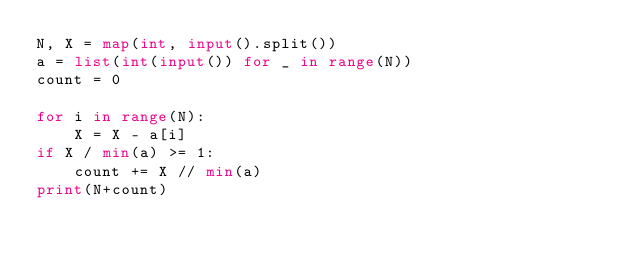<code> <loc_0><loc_0><loc_500><loc_500><_Python_>N, X = map(int, input().split())
a = list(int(input()) for _ in range(N))
count = 0

for i in range(N):
    X = X - a[i]
if X / min(a) >= 1:
    count += X // min(a)
print(N+count)</code> 